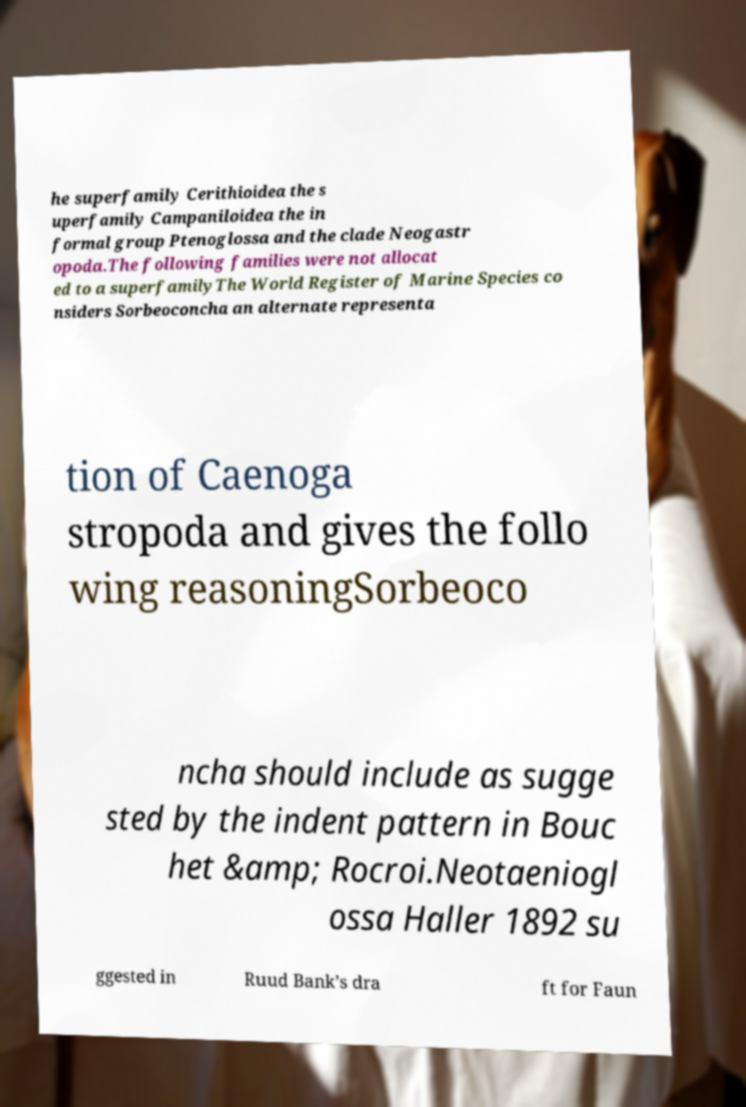For documentation purposes, I need the text within this image transcribed. Could you provide that? he superfamily Cerithioidea the s uperfamily Campaniloidea the in formal group Ptenoglossa and the clade Neogastr opoda.The following families were not allocat ed to a superfamilyThe World Register of Marine Species co nsiders Sorbeoconcha an alternate representa tion of Caenoga stropoda and gives the follo wing reasoningSorbeoco ncha should include as sugge sted by the indent pattern in Bouc het &amp; Rocroi.Neotaeniogl ossa Haller 1892 su ggested in Ruud Bank’s dra ft for Faun 